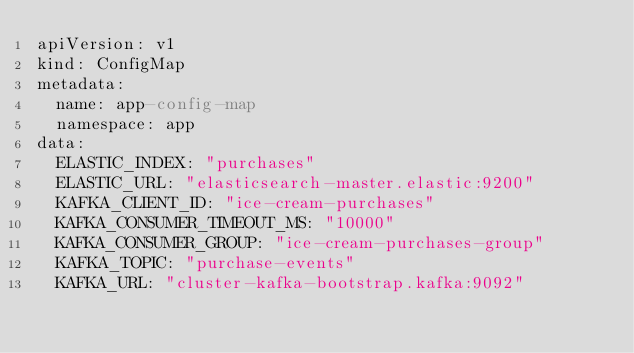<code> <loc_0><loc_0><loc_500><loc_500><_YAML_>apiVersion: v1
kind: ConfigMap
metadata:
  name: app-config-map
  namespace: app
data:
  ELASTIC_INDEX: "purchases"
  ELASTIC_URL: "elasticsearch-master.elastic:9200"
  KAFKA_CLIENT_ID: "ice-cream-purchases"
  KAFKA_CONSUMER_TIMEOUT_MS: "10000"
  KAFKA_CONSUMER_GROUP: "ice-cream-purchases-group"
  KAFKA_TOPIC: "purchase-events"
  KAFKA_URL: "cluster-kafka-bootstrap.kafka:9092"
</code> 